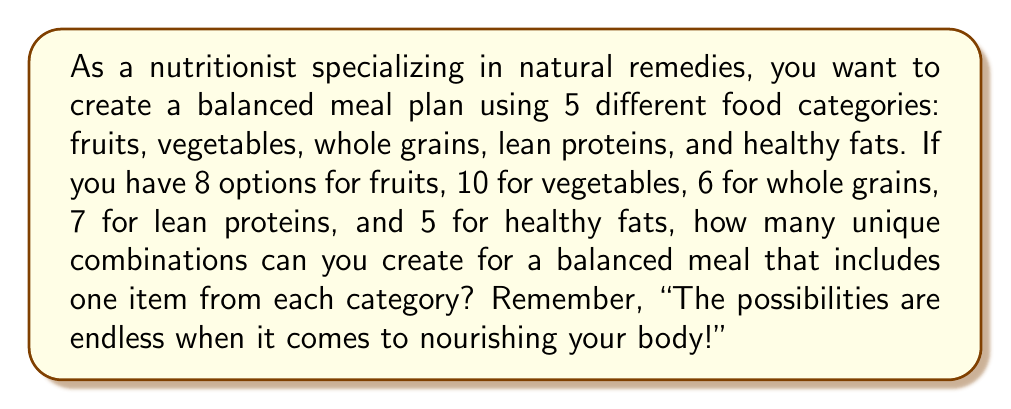Could you help me with this problem? Let's approach this step-by-step:

1) We are creating a meal plan by selecting one item from each of the 5 food categories.

2) For each category, we have the following number of choices:
   - Fruits: 8 options
   - Vegetables: 10 options
   - Whole grains: 6 options
   - Lean proteins: 7 options
   - Healthy fats: 5 options

3) According to the Multiplication Principle in combinatorics, if we have a series of independent choices, the total number of possible outcomes is the product of the number of possibilities for each choice.

4) In this case, we multiply the number of options for each category:

   $$8 \times 10 \times 6 \times 7 \times 5$$

5) Let's calculate:
   $$8 \times 10 = 80$$
   $$80 \times 6 = 480$$
   $$480 \times 7 = 3,360$$
   $$3,360 \times 5 = 16,800$$

Therefore, there are 16,800 unique combinations for creating a balanced meal plan with these options.
Answer: 16,800 combinations 